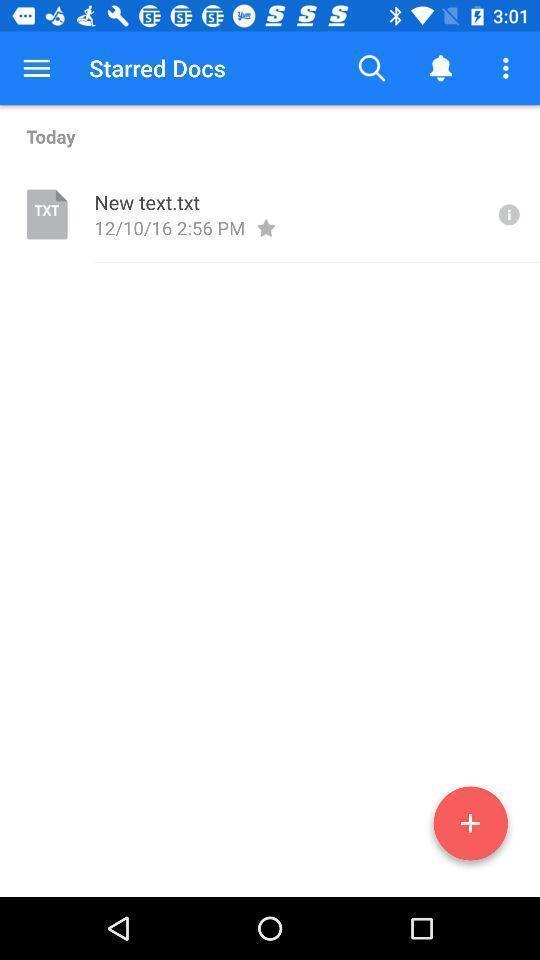Provide a description of this screenshot. Page showing location about document. 